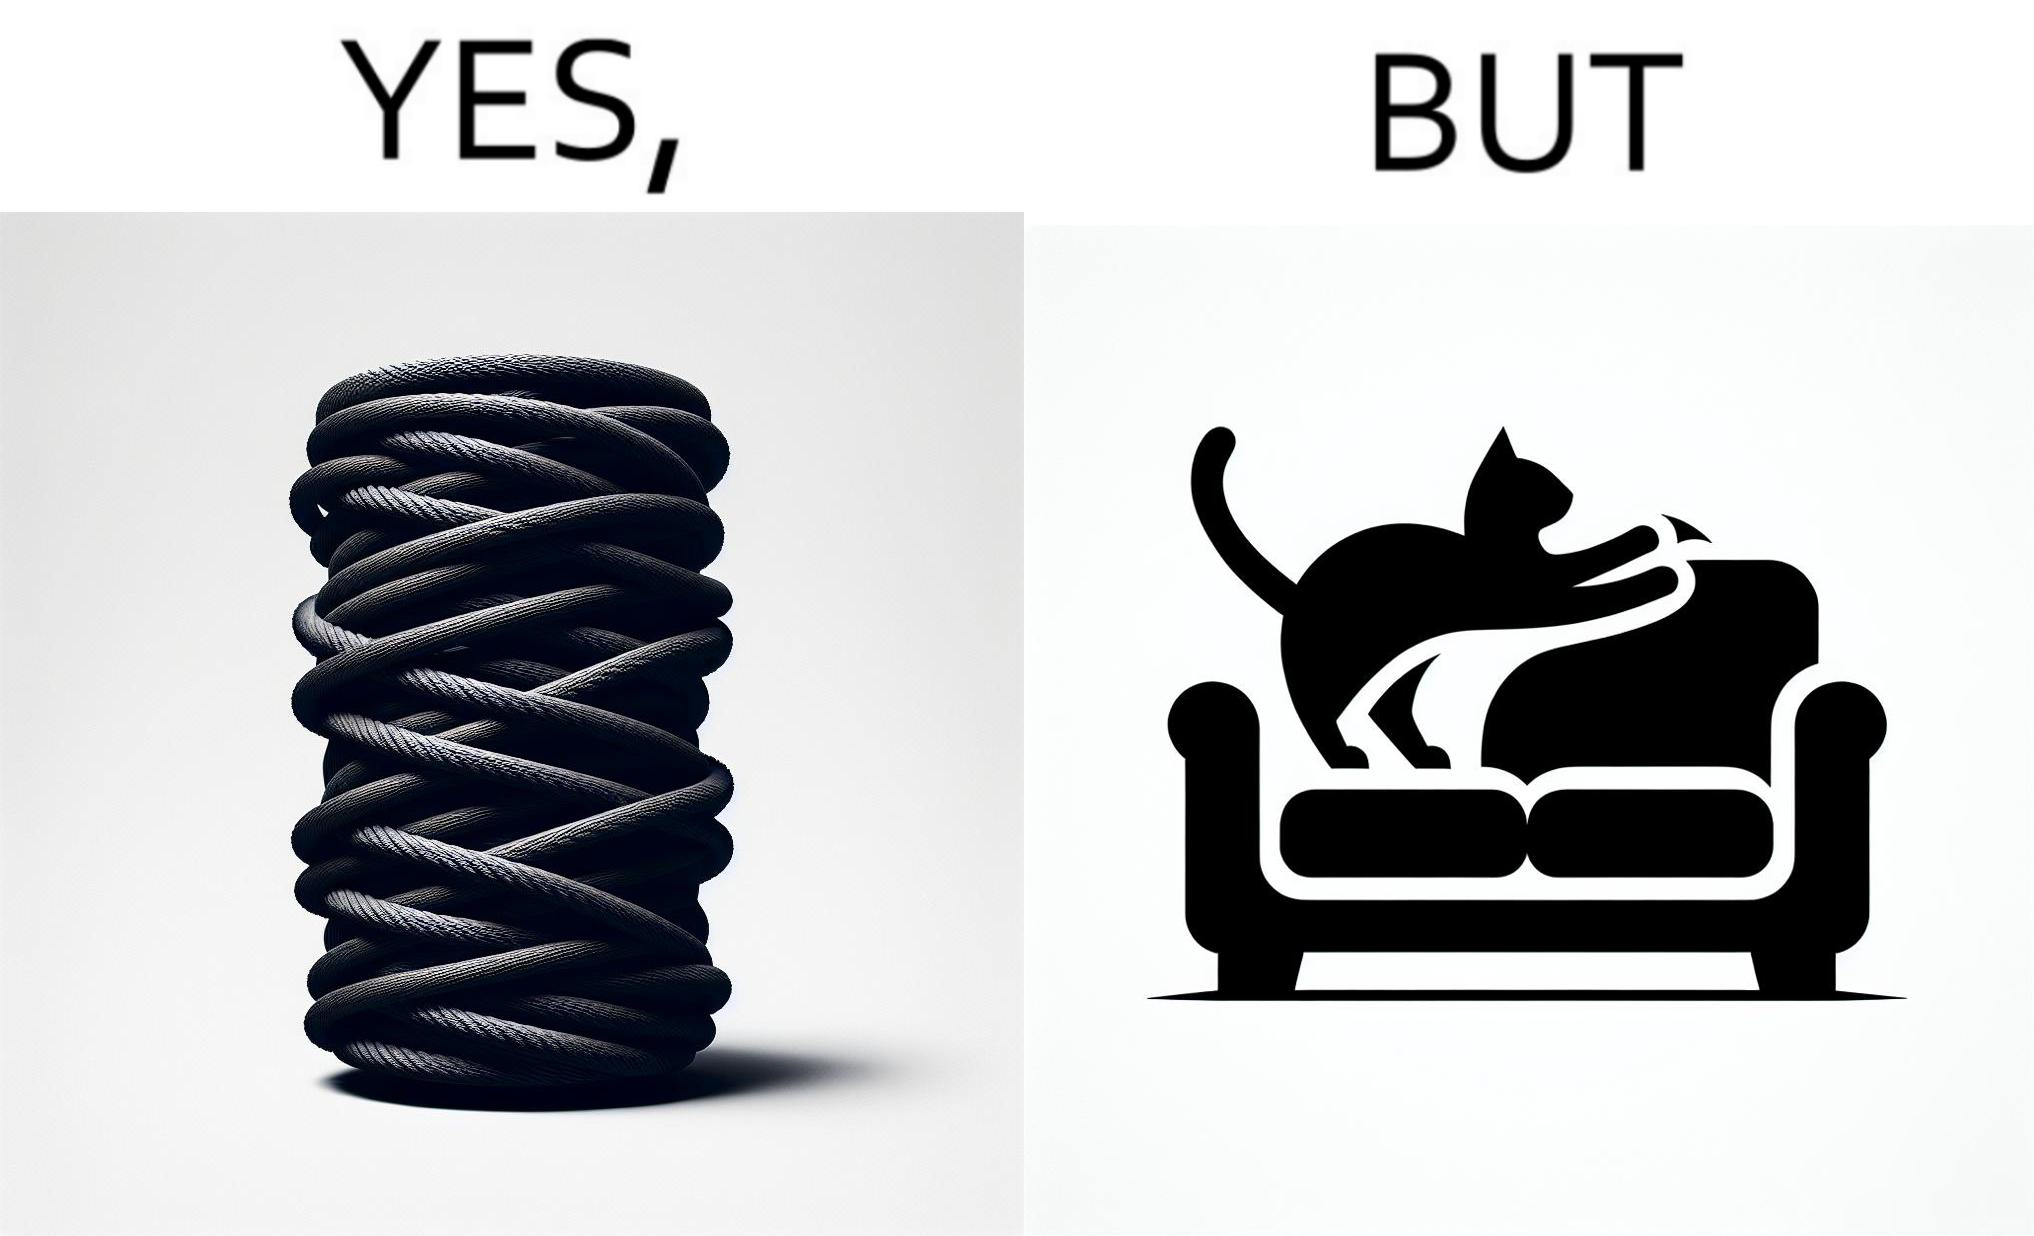Describe what you see in this image. The image is ironic, because in the first image a toy, purposed for the cat to play with is shown but in the second image the cat is comfortably enjoying  to play on the sides of sofa 